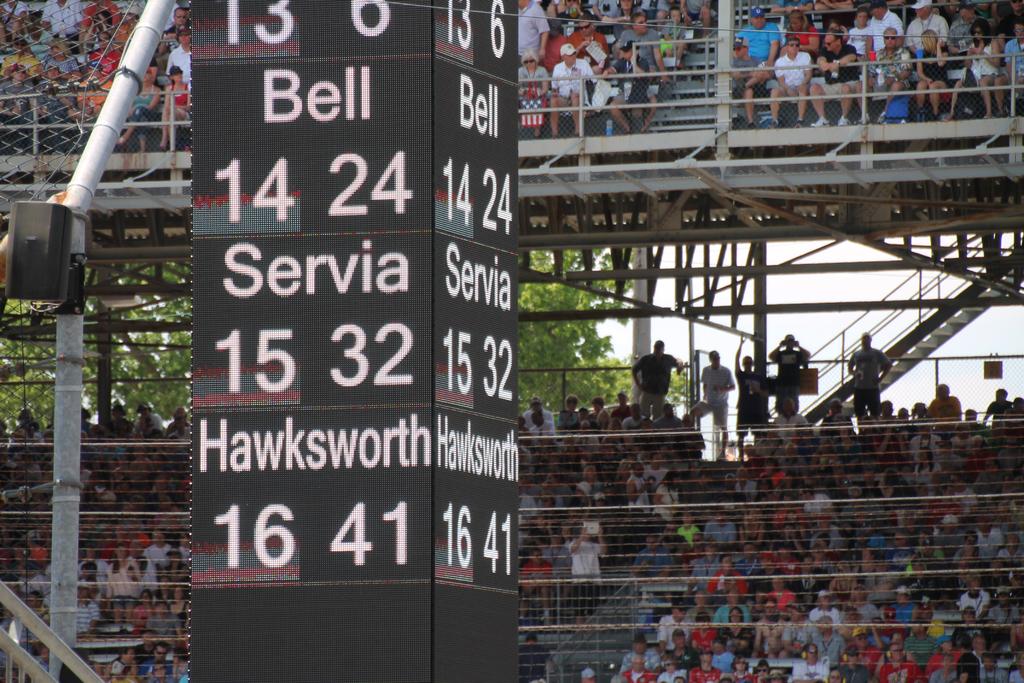What is the score for servia?
Make the answer very short. 15 32. What is the bottom team listed?
Offer a terse response. Hawksworth. 